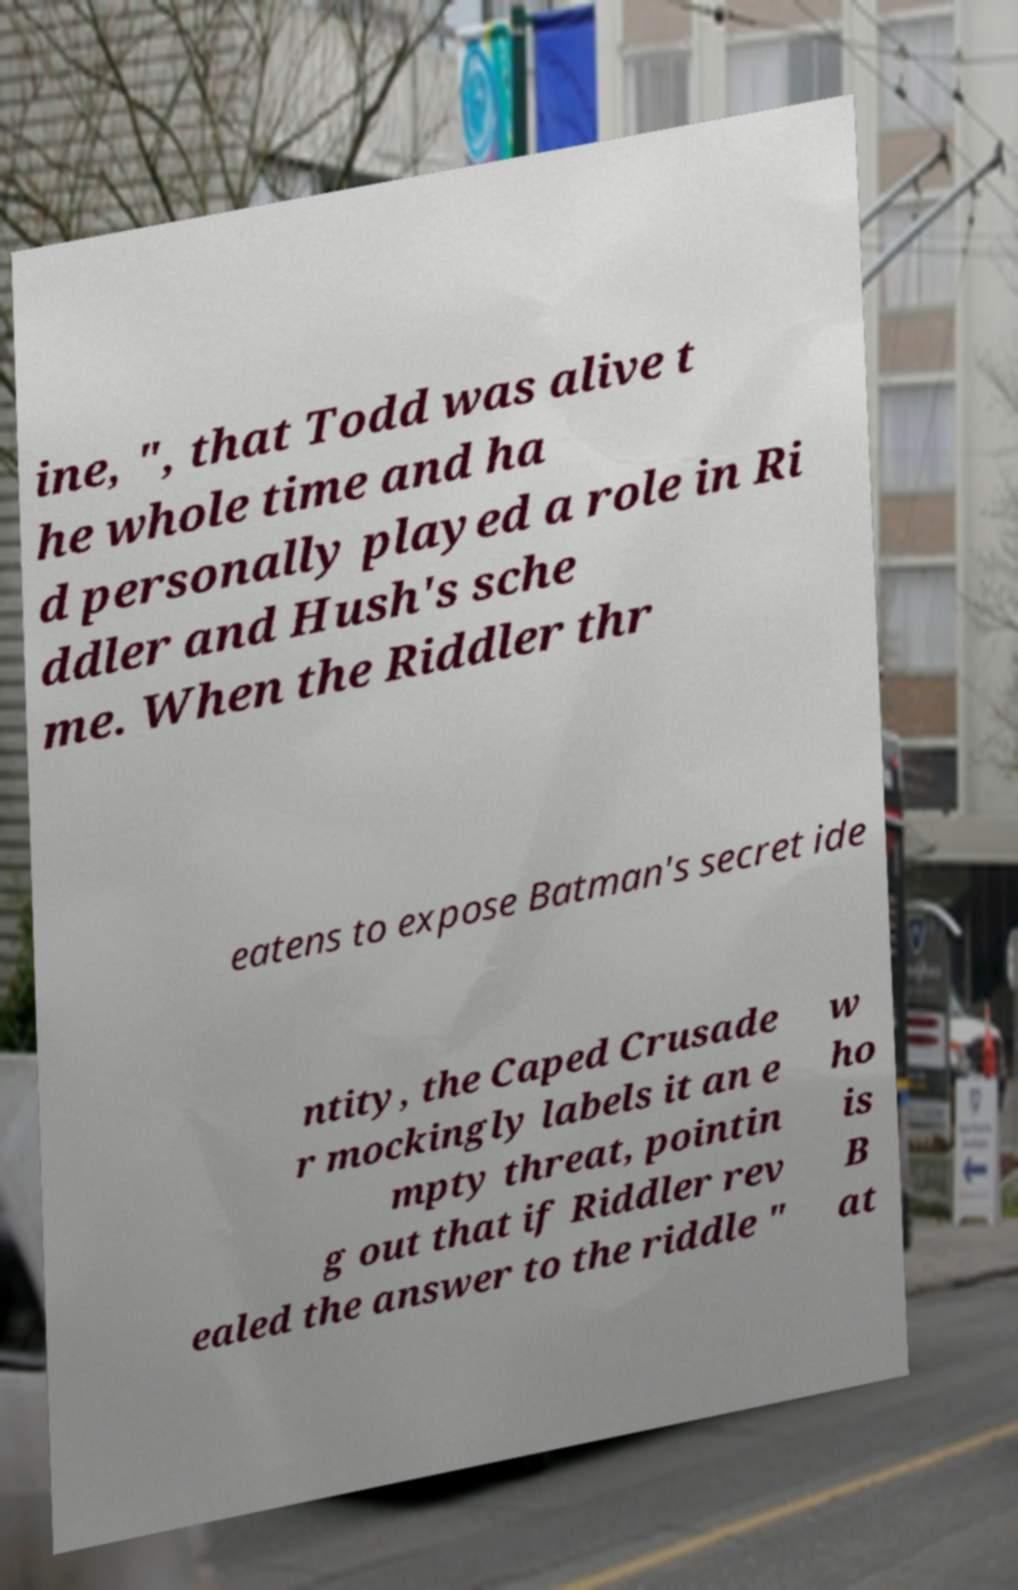Can you read and provide the text displayed in the image?This photo seems to have some interesting text. Can you extract and type it out for me? ine, ", that Todd was alive t he whole time and ha d personally played a role in Ri ddler and Hush's sche me. When the Riddler thr eatens to expose Batman's secret ide ntity, the Caped Crusade r mockingly labels it an e mpty threat, pointin g out that if Riddler rev ealed the answer to the riddle " w ho is B at 